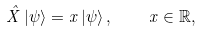<formula> <loc_0><loc_0><loc_500><loc_500>\hat { X } \left | \psi \right \rangle = x \left | \psi \right \rangle , \quad x \in \mathbb { R } ,</formula> 